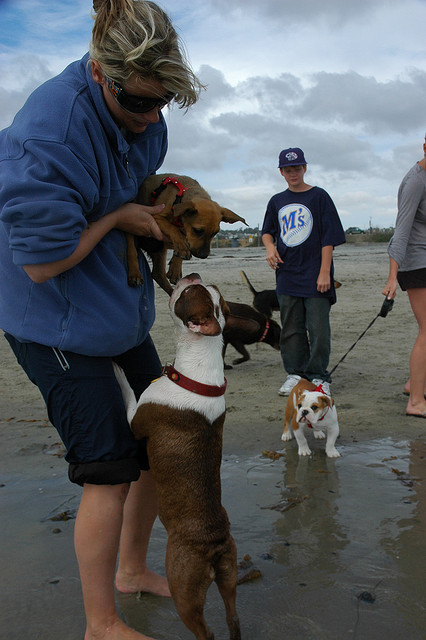Please transcribe the text information in this image. M's 